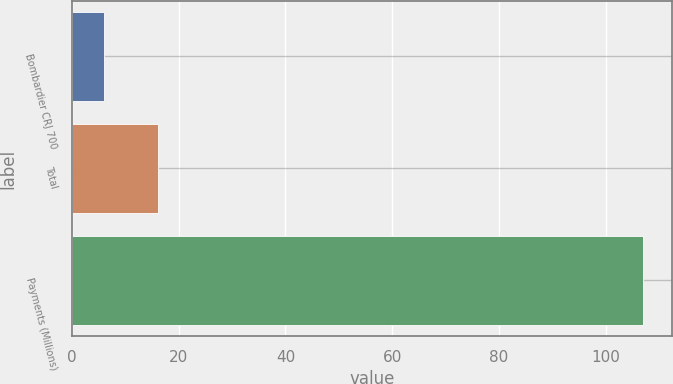Convert chart to OTSL. <chart><loc_0><loc_0><loc_500><loc_500><bar_chart><fcel>Bombardier CRJ 700<fcel>Total<fcel>Payments (Millions)<nl><fcel>6<fcel>16.1<fcel>107<nl></chart> 